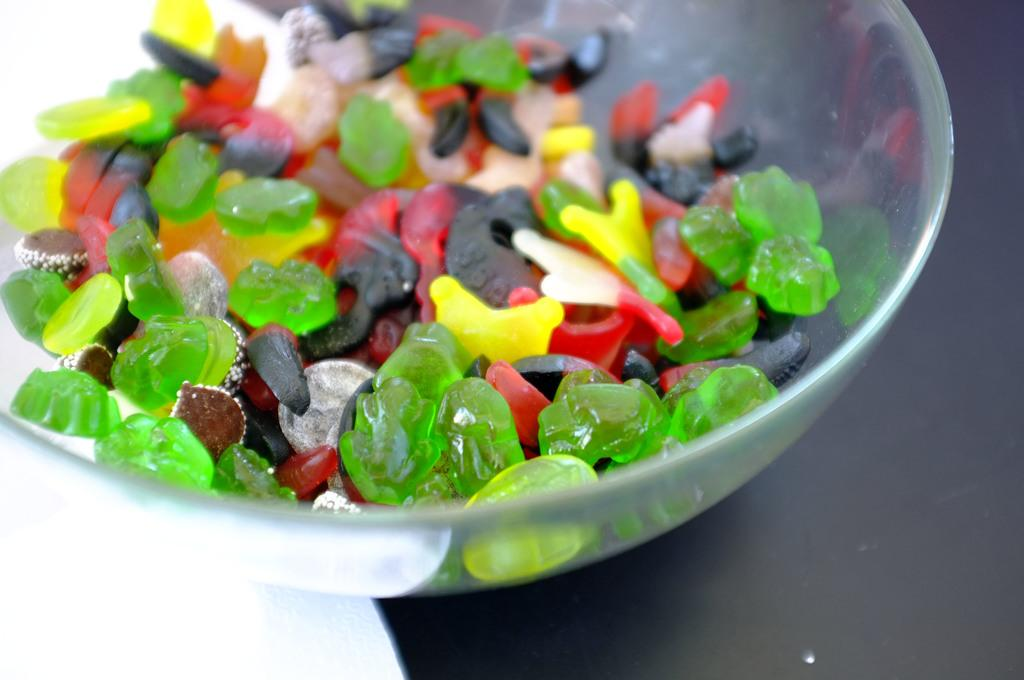What type of container is visible in the image? There is a glass bowl in the image. What is inside the glass bowl? The glass bowl contains candy. Can you describe the appearance of the candy? The candy is in different colors. Is there a request for dirt in the image? No, there is no mention of dirt or any request for it in the image. What type of substance is being requested in the image? There is no substance being requested in the image. 